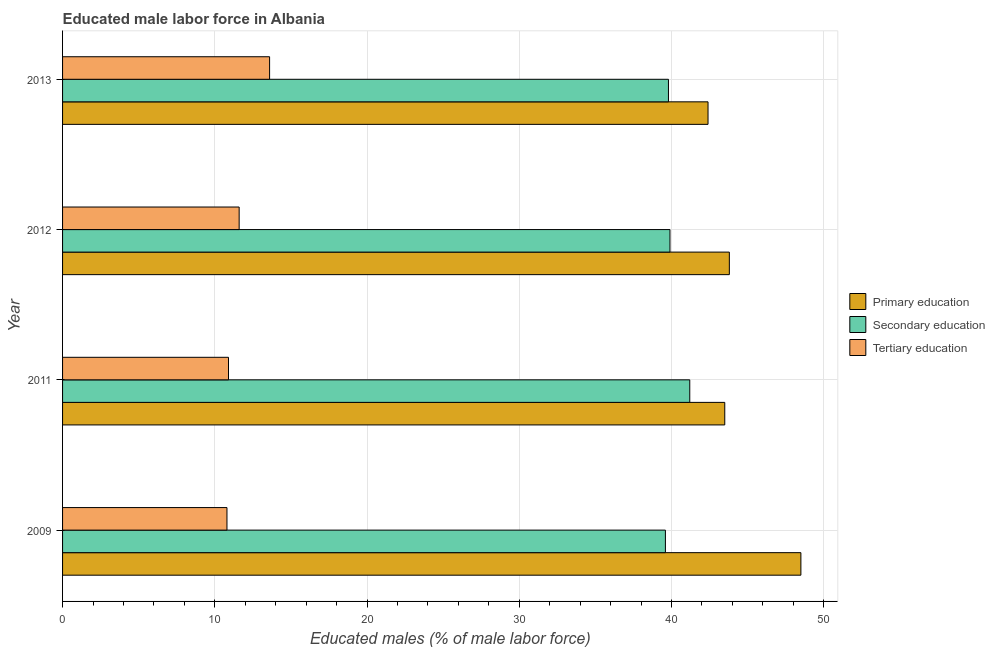How many bars are there on the 2nd tick from the bottom?
Offer a terse response. 3. What is the label of the 2nd group of bars from the top?
Your response must be concise. 2012. In how many cases, is the number of bars for a given year not equal to the number of legend labels?
Keep it short and to the point. 0. What is the percentage of male labor force who received primary education in 2013?
Give a very brief answer. 42.4. Across all years, what is the maximum percentage of male labor force who received secondary education?
Your answer should be compact. 41.2. Across all years, what is the minimum percentage of male labor force who received secondary education?
Your answer should be very brief. 39.6. In which year was the percentage of male labor force who received tertiary education maximum?
Keep it short and to the point. 2013. What is the total percentage of male labor force who received tertiary education in the graph?
Offer a terse response. 46.9. What is the difference between the percentage of male labor force who received secondary education in 2012 and that in 2013?
Keep it short and to the point. 0.1. What is the difference between the percentage of male labor force who received primary education in 2012 and the percentage of male labor force who received tertiary education in 2013?
Provide a succinct answer. 30.2. What is the average percentage of male labor force who received primary education per year?
Provide a short and direct response. 44.55. In the year 2012, what is the difference between the percentage of male labor force who received tertiary education and percentage of male labor force who received primary education?
Make the answer very short. -32.2. In how many years, is the percentage of male labor force who received primary education greater than 42 %?
Your answer should be compact. 4. What is the ratio of the percentage of male labor force who received primary education in 2012 to that in 2013?
Provide a succinct answer. 1.03. Is the difference between the percentage of male labor force who received primary education in 2011 and 2013 greater than the difference between the percentage of male labor force who received tertiary education in 2011 and 2013?
Offer a very short reply. Yes. What is the difference between the highest and the second highest percentage of male labor force who received primary education?
Ensure brevity in your answer.  4.7. What does the 2nd bar from the top in 2011 represents?
Keep it short and to the point. Secondary education. What does the 3rd bar from the bottom in 2009 represents?
Offer a terse response. Tertiary education. Is it the case that in every year, the sum of the percentage of male labor force who received primary education and percentage of male labor force who received secondary education is greater than the percentage of male labor force who received tertiary education?
Your answer should be compact. Yes. How many bars are there?
Provide a short and direct response. 12. Does the graph contain any zero values?
Keep it short and to the point. No. How are the legend labels stacked?
Keep it short and to the point. Vertical. What is the title of the graph?
Offer a very short reply. Educated male labor force in Albania. Does "Capital account" appear as one of the legend labels in the graph?
Make the answer very short. No. What is the label or title of the X-axis?
Make the answer very short. Educated males (% of male labor force). What is the Educated males (% of male labor force) in Primary education in 2009?
Offer a terse response. 48.5. What is the Educated males (% of male labor force) of Secondary education in 2009?
Offer a very short reply. 39.6. What is the Educated males (% of male labor force) in Tertiary education in 2009?
Your answer should be compact. 10.8. What is the Educated males (% of male labor force) of Primary education in 2011?
Your response must be concise. 43.5. What is the Educated males (% of male labor force) in Secondary education in 2011?
Your answer should be very brief. 41.2. What is the Educated males (% of male labor force) in Tertiary education in 2011?
Keep it short and to the point. 10.9. What is the Educated males (% of male labor force) of Primary education in 2012?
Offer a very short reply. 43.8. What is the Educated males (% of male labor force) of Secondary education in 2012?
Offer a very short reply. 39.9. What is the Educated males (% of male labor force) of Tertiary education in 2012?
Offer a very short reply. 11.6. What is the Educated males (% of male labor force) in Primary education in 2013?
Your answer should be compact. 42.4. What is the Educated males (% of male labor force) in Secondary education in 2013?
Ensure brevity in your answer.  39.8. What is the Educated males (% of male labor force) in Tertiary education in 2013?
Provide a short and direct response. 13.6. Across all years, what is the maximum Educated males (% of male labor force) of Primary education?
Make the answer very short. 48.5. Across all years, what is the maximum Educated males (% of male labor force) of Secondary education?
Provide a succinct answer. 41.2. Across all years, what is the maximum Educated males (% of male labor force) of Tertiary education?
Your answer should be very brief. 13.6. Across all years, what is the minimum Educated males (% of male labor force) of Primary education?
Ensure brevity in your answer.  42.4. Across all years, what is the minimum Educated males (% of male labor force) of Secondary education?
Provide a succinct answer. 39.6. Across all years, what is the minimum Educated males (% of male labor force) of Tertiary education?
Your response must be concise. 10.8. What is the total Educated males (% of male labor force) in Primary education in the graph?
Provide a short and direct response. 178.2. What is the total Educated males (% of male labor force) of Secondary education in the graph?
Provide a succinct answer. 160.5. What is the total Educated males (% of male labor force) of Tertiary education in the graph?
Provide a succinct answer. 46.9. What is the difference between the Educated males (% of male labor force) of Tertiary education in 2009 and that in 2011?
Offer a very short reply. -0.1. What is the difference between the Educated males (% of male labor force) of Secondary education in 2009 and that in 2012?
Give a very brief answer. -0.3. What is the difference between the Educated males (% of male labor force) of Primary education in 2011 and that in 2012?
Ensure brevity in your answer.  -0.3. What is the difference between the Educated males (% of male labor force) in Secondary education in 2011 and that in 2012?
Make the answer very short. 1.3. What is the difference between the Educated males (% of male labor force) in Secondary education in 2011 and that in 2013?
Your response must be concise. 1.4. What is the difference between the Educated males (% of male labor force) in Tertiary education in 2011 and that in 2013?
Make the answer very short. -2.7. What is the difference between the Educated males (% of male labor force) in Primary education in 2012 and that in 2013?
Offer a terse response. 1.4. What is the difference between the Educated males (% of male labor force) of Primary education in 2009 and the Educated males (% of male labor force) of Secondary education in 2011?
Your answer should be very brief. 7.3. What is the difference between the Educated males (% of male labor force) of Primary education in 2009 and the Educated males (% of male labor force) of Tertiary education in 2011?
Give a very brief answer. 37.6. What is the difference between the Educated males (% of male labor force) of Secondary education in 2009 and the Educated males (% of male labor force) of Tertiary education in 2011?
Offer a terse response. 28.7. What is the difference between the Educated males (% of male labor force) in Primary education in 2009 and the Educated males (% of male labor force) in Secondary education in 2012?
Offer a terse response. 8.6. What is the difference between the Educated males (% of male labor force) in Primary education in 2009 and the Educated males (% of male labor force) in Tertiary education in 2012?
Give a very brief answer. 36.9. What is the difference between the Educated males (% of male labor force) in Secondary education in 2009 and the Educated males (% of male labor force) in Tertiary education in 2012?
Offer a very short reply. 28. What is the difference between the Educated males (% of male labor force) of Primary education in 2009 and the Educated males (% of male labor force) of Secondary education in 2013?
Keep it short and to the point. 8.7. What is the difference between the Educated males (% of male labor force) in Primary education in 2009 and the Educated males (% of male labor force) in Tertiary education in 2013?
Provide a short and direct response. 34.9. What is the difference between the Educated males (% of male labor force) in Primary education in 2011 and the Educated males (% of male labor force) in Tertiary education in 2012?
Your answer should be compact. 31.9. What is the difference between the Educated males (% of male labor force) of Secondary education in 2011 and the Educated males (% of male labor force) of Tertiary education in 2012?
Offer a very short reply. 29.6. What is the difference between the Educated males (% of male labor force) of Primary education in 2011 and the Educated males (% of male labor force) of Secondary education in 2013?
Provide a short and direct response. 3.7. What is the difference between the Educated males (% of male labor force) of Primary education in 2011 and the Educated males (% of male labor force) of Tertiary education in 2013?
Offer a very short reply. 29.9. What is the difference between the Educated males (% of male labor force) in Secondary education in 2011 and the Educated males (% of male labor force) in Tertiary education in 2013?
Offer a very short reply. 27.6. What is the difference between the Educated males (% of male labor force) of Primary education in 2012 and the Educated males (% of male labor force) of Secondary education in 2013?
Your response must be concise. 4. What is the difference between the Educated males (% of male labor force) of Primary education in 2012 and the Educated males (% of male labor force) of Tertiary education in 2013?
Your response must be concise. 30.2. What is the difference between the Educated males (% of male labor force) of Secondary education in 2012 and the Educated males (% of male labor force) of Tertiary education in 2013?
Your response must be concise. 26.3. What is the average Educated males (% of male labor force) in Primary education per year?
Provide a short and direct response. 44.55. What is the average Educated males (% of male labor force) in Secondary education per year?
Your answer should be compact. 40.12. What is the average Educated males (% of male labor force) in Tertiary education per year?
Offer a very short reply. 11.72. In the year 2009, what is the difference between the Educated males (% of male labor force) of Primary education and Educated males (% of male labor force) of Secondary education?
Offer a terse response. 8.9. In the year 2009, what is the difference between the Educated males (% of male labor force) of Primary education and Educated males (% of male labor force) of Tertiary education?
Your answer should be very brief. 37.7. In the year 2009, what is the difference between the Educated males (% of male labor force) of Secondary education and Educated males (% of male labor force) of Tertiary education?
Provide a succinct answer. 28.8. In the year 2011, what is the difference between the Educated males (% of male labor force) of Primary education and Educated males (% of male labor force) of Secondary education?
Provide a succinct answer. 2.3. In the year 2011, what is the difference between the Educated males (% of male labor force) of Primary education and Educated males (% of male labor force) of Tertiary education?
Your answer should be compact. 32.6. In the year 2011, what is the difference between the Educated males (% of male labor force) of Secondary education and Educated males (% of male labor force) of Tertiary education?
Provide a succinct answer. 30.3. In the year 2012, what is the difference between the Educated males (% of male labor force) of Primary education and Educated males (% of male labor force) of Secondary education?
Provide a short and direct response. 3.9. In the year 2012, what is the difference between the Educated males (% of male labor force) in Primary education and Educated males (% of male labor force) in Tertiary education?
Provide a short and direct response. 32.2. In the year 2012, what is the difference between the Educated males (% of male labor force) in Secondary education and Educated males (% of male labor force) in Tertiary education?
Provide a succinct answer. 28.3. In the year 2013, what is the difference between the Educated males (% of male labor force) in Primary education and Educated males (% of male labor force) in Secondary education?
Give a very brief answer. 2.6. In the year 2013, what is the difference between the Educated males (% of male labor force) of Primary education and Educated males (% of male labor force) of Tertiary education?
Keep it short and to the point. 28.8. In the year 2013, what is the difference between the Educated males (% of male labor force) of Secondary education and Educated males (% of male labor force) of Tertiary education?
Give a very brief answer. 26.2. What is the ratio of the Educated males (% of male labor force) in Primary education in 2009 to that in 2011?
Your answer should be very brief. 1.11. What is the ratio of the Educated males (% of male labor force) of Secondary education in 2009 to that in 2011?
Keep it short and to the point. 0.96. What is the ratio of the Educated males (% of male labor force) of Tertiary education in 2009 to that in 2011?
Your response must be concise. 0.99. What is the ratio of the Educated males (% of male labor force) in Primary education in 2009 to that in 2012?
Your answer should be very brief. 1.11. What is the ratio of the Educated males (% of male labor force) in Secondary education in 2009 to that in 2012?
Provide a succinct answer. 0.99. What is the ratio of the Educated males (% of male labor force) in Tertiary education in 2009 to that in 2012?
Keep it short and to the point. 0.93. What is the ratio of the Educated males (% of male labor force) in Primary education in 2009 to that in 2013?
Your answer should be very brief. 1.14. What is the ratio of the Educated males (% of male labor force) in Secondary education in 2009 to that in 2013?
Provide a short and direct response. 0.99. What is the ratio of the Educated males (% of male labor force) of Tertiary education in 2009 to that in 2013?
Your response must be concise. 0.79. What is the ratio of the Educated males (% of male labor force) in Primary education in 2011 to that in 2012?
Offer a terse response. 0.99. What is the ratio of the Educated males (% of male labor force) of Secondary education in 2011 to that in 2012?
Offer a very short reply. 1.03. What is the ratio of the Educated males (% of male labor force) in Tertiary education in 2011 to that in 2012?
Make the answer very short. 0.94. What is the ratio of the Educated males (% of male labor force) of Primary education in 2011 to that in 2013?
Your answer should be compact. 1.03. What is the ratio of the Educated males (% of male labor force) in Secondary education in 2011 to that in 2013?
Make the answer very short. 1.04. What is the ratio of the Educated males (% of male labor force) in Tertiary education in 2011 to that in 2013?
Offer a very short reply. 0.8. What is the ratio of the Educated males (% of male labor force) of Primary education in 2012 to that in 2013?
Offer a very short reply. 1.03. What is the ratio of the Educated males (% of male labor force) of Secondary education in 2012 to that in 2013?
Give a very brief answer. 1. What is the ratio of the Educated males (% of male labor force) of Tertiary education in 2012 to that in 2013?
Provide a succinct answer. 0.85. What is the difference between the highest and the lowest Educated males (% of male labor force) in Secondary education?
Give a very brief answer. 1.6. 